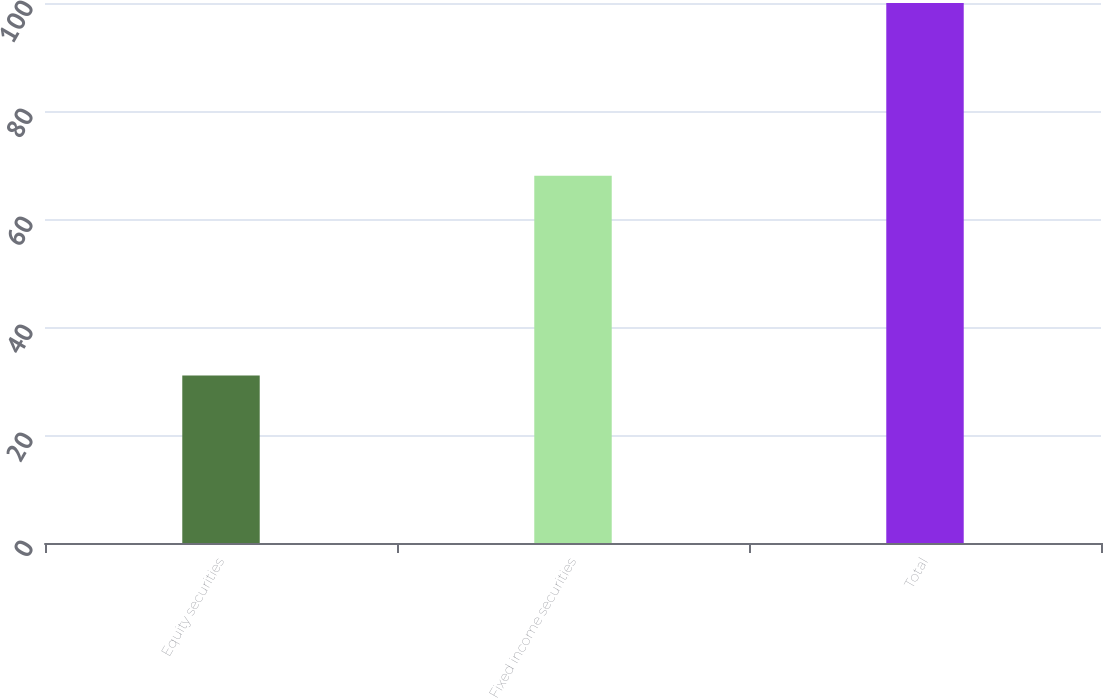<chart> <loc_0><loc_0><loc_500><loc_500><bar_chart><fcel>Equity securities<fcel>Fixed income securities<fcel>Total<nl><fcel>31<fcel>68<fcel>100<nl></chart> 